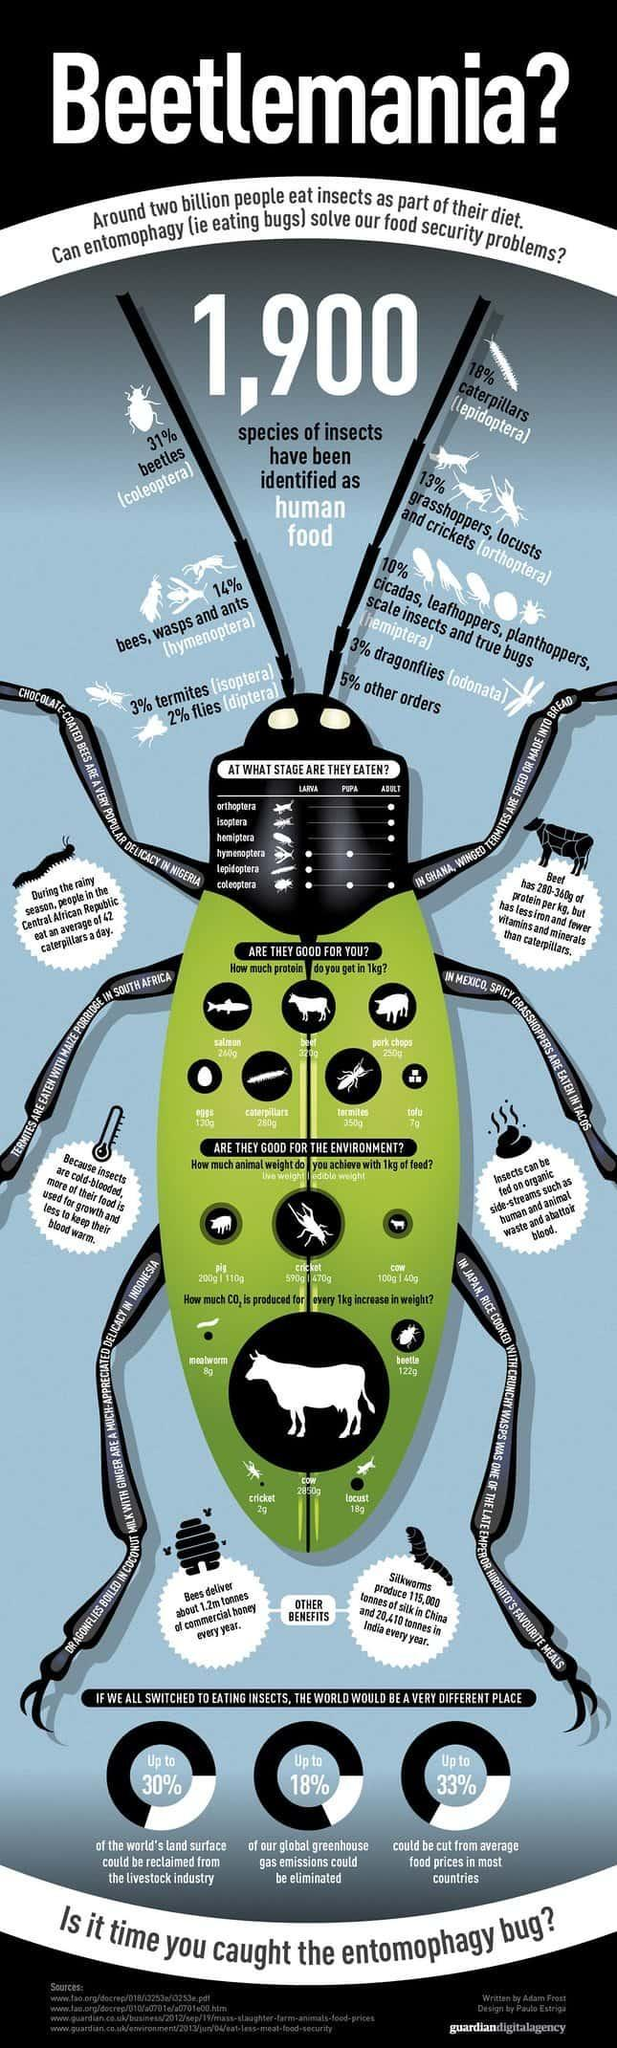What are the stages of insects mentioned in this infographic?
Answer the question with a short phrase. Larva, Pupa, Adult At which stage Isoptera eaten? Adult What percentage of insects are caterpillars? 18% Ant belongs to which order of insects? hymenoptera How much protein in 1kg of eggs? 130g How much protein in 1kg of pork chops? 250g Leafhopper belongs to which order of insects? hemiptera Beetle belongs to which order of insects? coleoptera In how many orders insects eaten after they become adults? 3 What percentage of insects are not beetles? 69% 